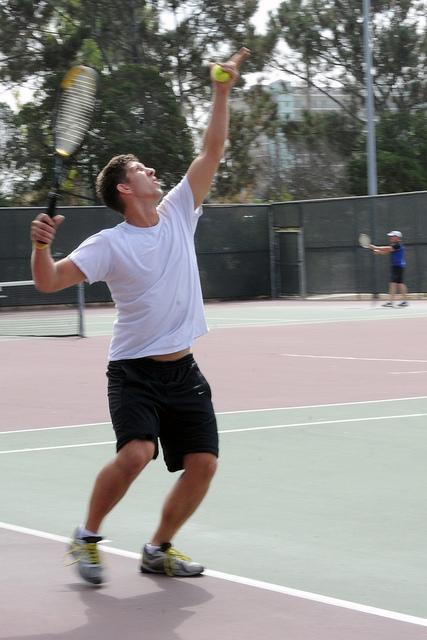Is the ball in play?
Give a very brief answer. Yes. Is there another person in the picture?
Keep it brief. Yes. What is the man about to do?
Concise answer only. Serve. Does the player have his shirt tucked in?
Short answer required. No. 